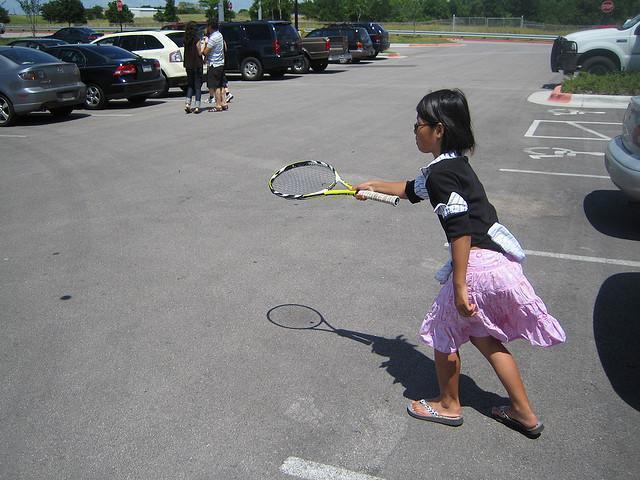Who plays the same sport?
Choose the correct response, then elucidate: 'Answer: answer
Rationale: rationale.'
Options: Serena williams, otis nixon, alex morgan, danica patrick. Answer: serena williams.
Rationale: The girl is holding a tennis racquet, not a baseball bat, steering wheel, or soccer ball. 